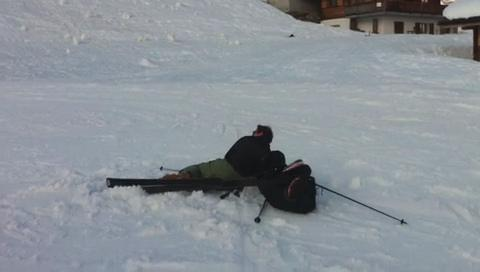What happened to this person?

Choices:
A) slept
B) ate food
C) strapped
D) fell down fell down 